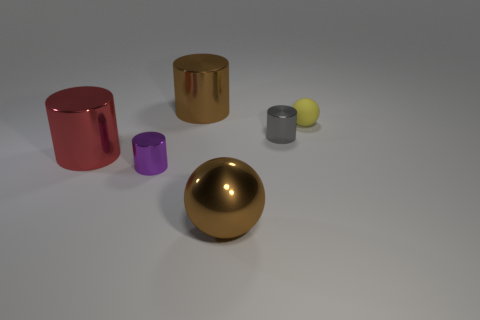Subtract all green cylinders. Subtract all blue spheres. How many cylinders are left? 4 Add 2 metallic objects. How many objects exist? 8 Subtract all balls. How many objects are left? 4 Subtract 1 gray cylinders. How many objects are left? 5 Subtract all tiny cyan metal cylinders. Subtract all small metal things. How many objects are left? 4 Add 1 large red things. How many large red things are left? 2 Add 2 big metal spheres. How many big metal spheres exist? 3 